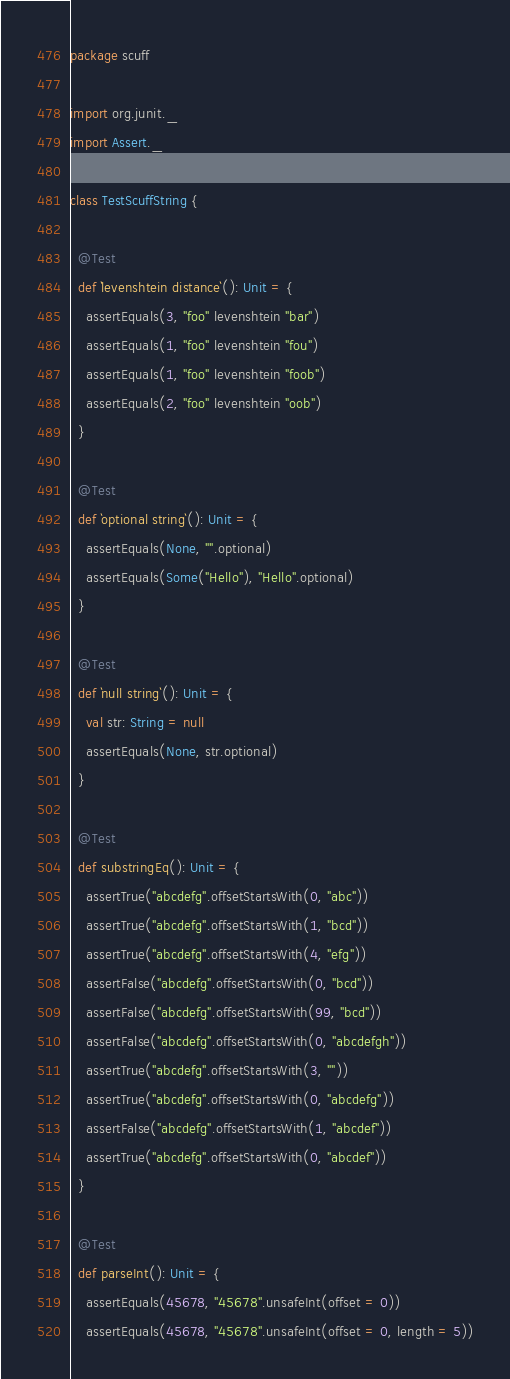Convert code to text. <code><loc_0><loc_0><loc_500><loc_500><_Scala_>package scuff

import org.junit._
import Assert._

class TestScuffString {

  @Test
  def `levenshtein distance`(): Unit = {
    assertEquals(3, "foo" levenshtein "bar")
    assertEquals(1, "foo" levenshtein "fou")
    assertEquals(1, "foo" levenshtein "foob")
    assertEquals(2, "foo" levenshtein "oob")
  }

  @Test
  def `optional string`(): Unit = {
    assertEquals(None, "".optional)
    assertEquals(Some("Hello"), "Hello".optional)
  }

  @Test
  def `null string`(): Unit = {
    val str: String = null
    assertEquals(None, str.optional)
  }

  @Test
  def substringEq(): Unit = {
    assertTrue("abcdefg".offsetStartsWith(0, "abc"))
    assertTrue("abcdefg".offsetStartsWith(1, "bcd"))
    assertTrue("abcdefg".offsetStartsWith(4, "efg"))
    assertFalse("abcdefg".offsetStartsWith(0, "bcd"))
    assertFalse("abcdefg".offsetStartsWith(99, "bcd"))
    assertFalse("abcdefg".offsetStartsWith(0, "abcdefgh"))
    assertTrue("abcdefg".offsetStartsWith(3, ""))
    assertTrue("abcdefg".offsetStartsWith(0, "abcdefg"))
    assertFalse("abcdefg".offsetStartsWith(1, "abcdef"))
    assertTrue("abcdefg".offsetStartsWith(0, "abcdef"))
  }

  @Test
  def parseInt(): Unit = {
    assertEquals(45678, "45678".unsafeInt(offset = 0))
    assertEquals(45678, "45678".unsafeInt(offset = 0, length = 5))</code> 